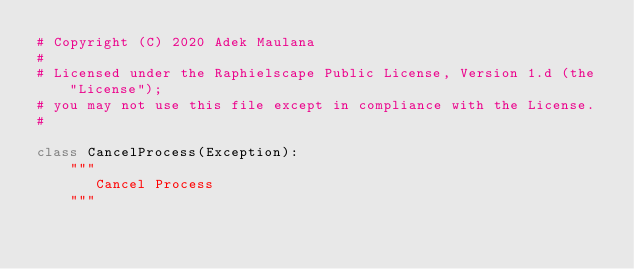<code> <loc_0><loc_0><loc_500><loc_500><_Python_># Copyright (C) 2020 Adek Maulana
#
# Licensed under the Raphielscape Public License, Version 1.d (the "License");
# you may not use this file except in compliance with the License.
#

class CancelProcess(Exception):
    """
       Cancel Process
    """</code> 